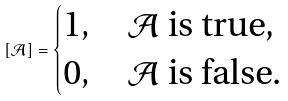<formula> <loc_0><loc_0><loc_500><loc_500>[ \mathcal { A } ] = \begin{cases} 1 , & \mathcal { A } \text { is true,} \\ 0 , & \mathcal { A } \text { is false.} \end{cases}</formula> 